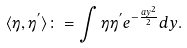Convert formula to latex. <formula><loc_0><loc_0><loc_500><loc_500>\langle \eta , \eta ^ { ^ { \prime } } \rangle \colon = \int \eta \eta ^ { ^ { \prime } } e ^ { - \frac { a y ^ { 2 } } { 2 } } d y .</formula> 